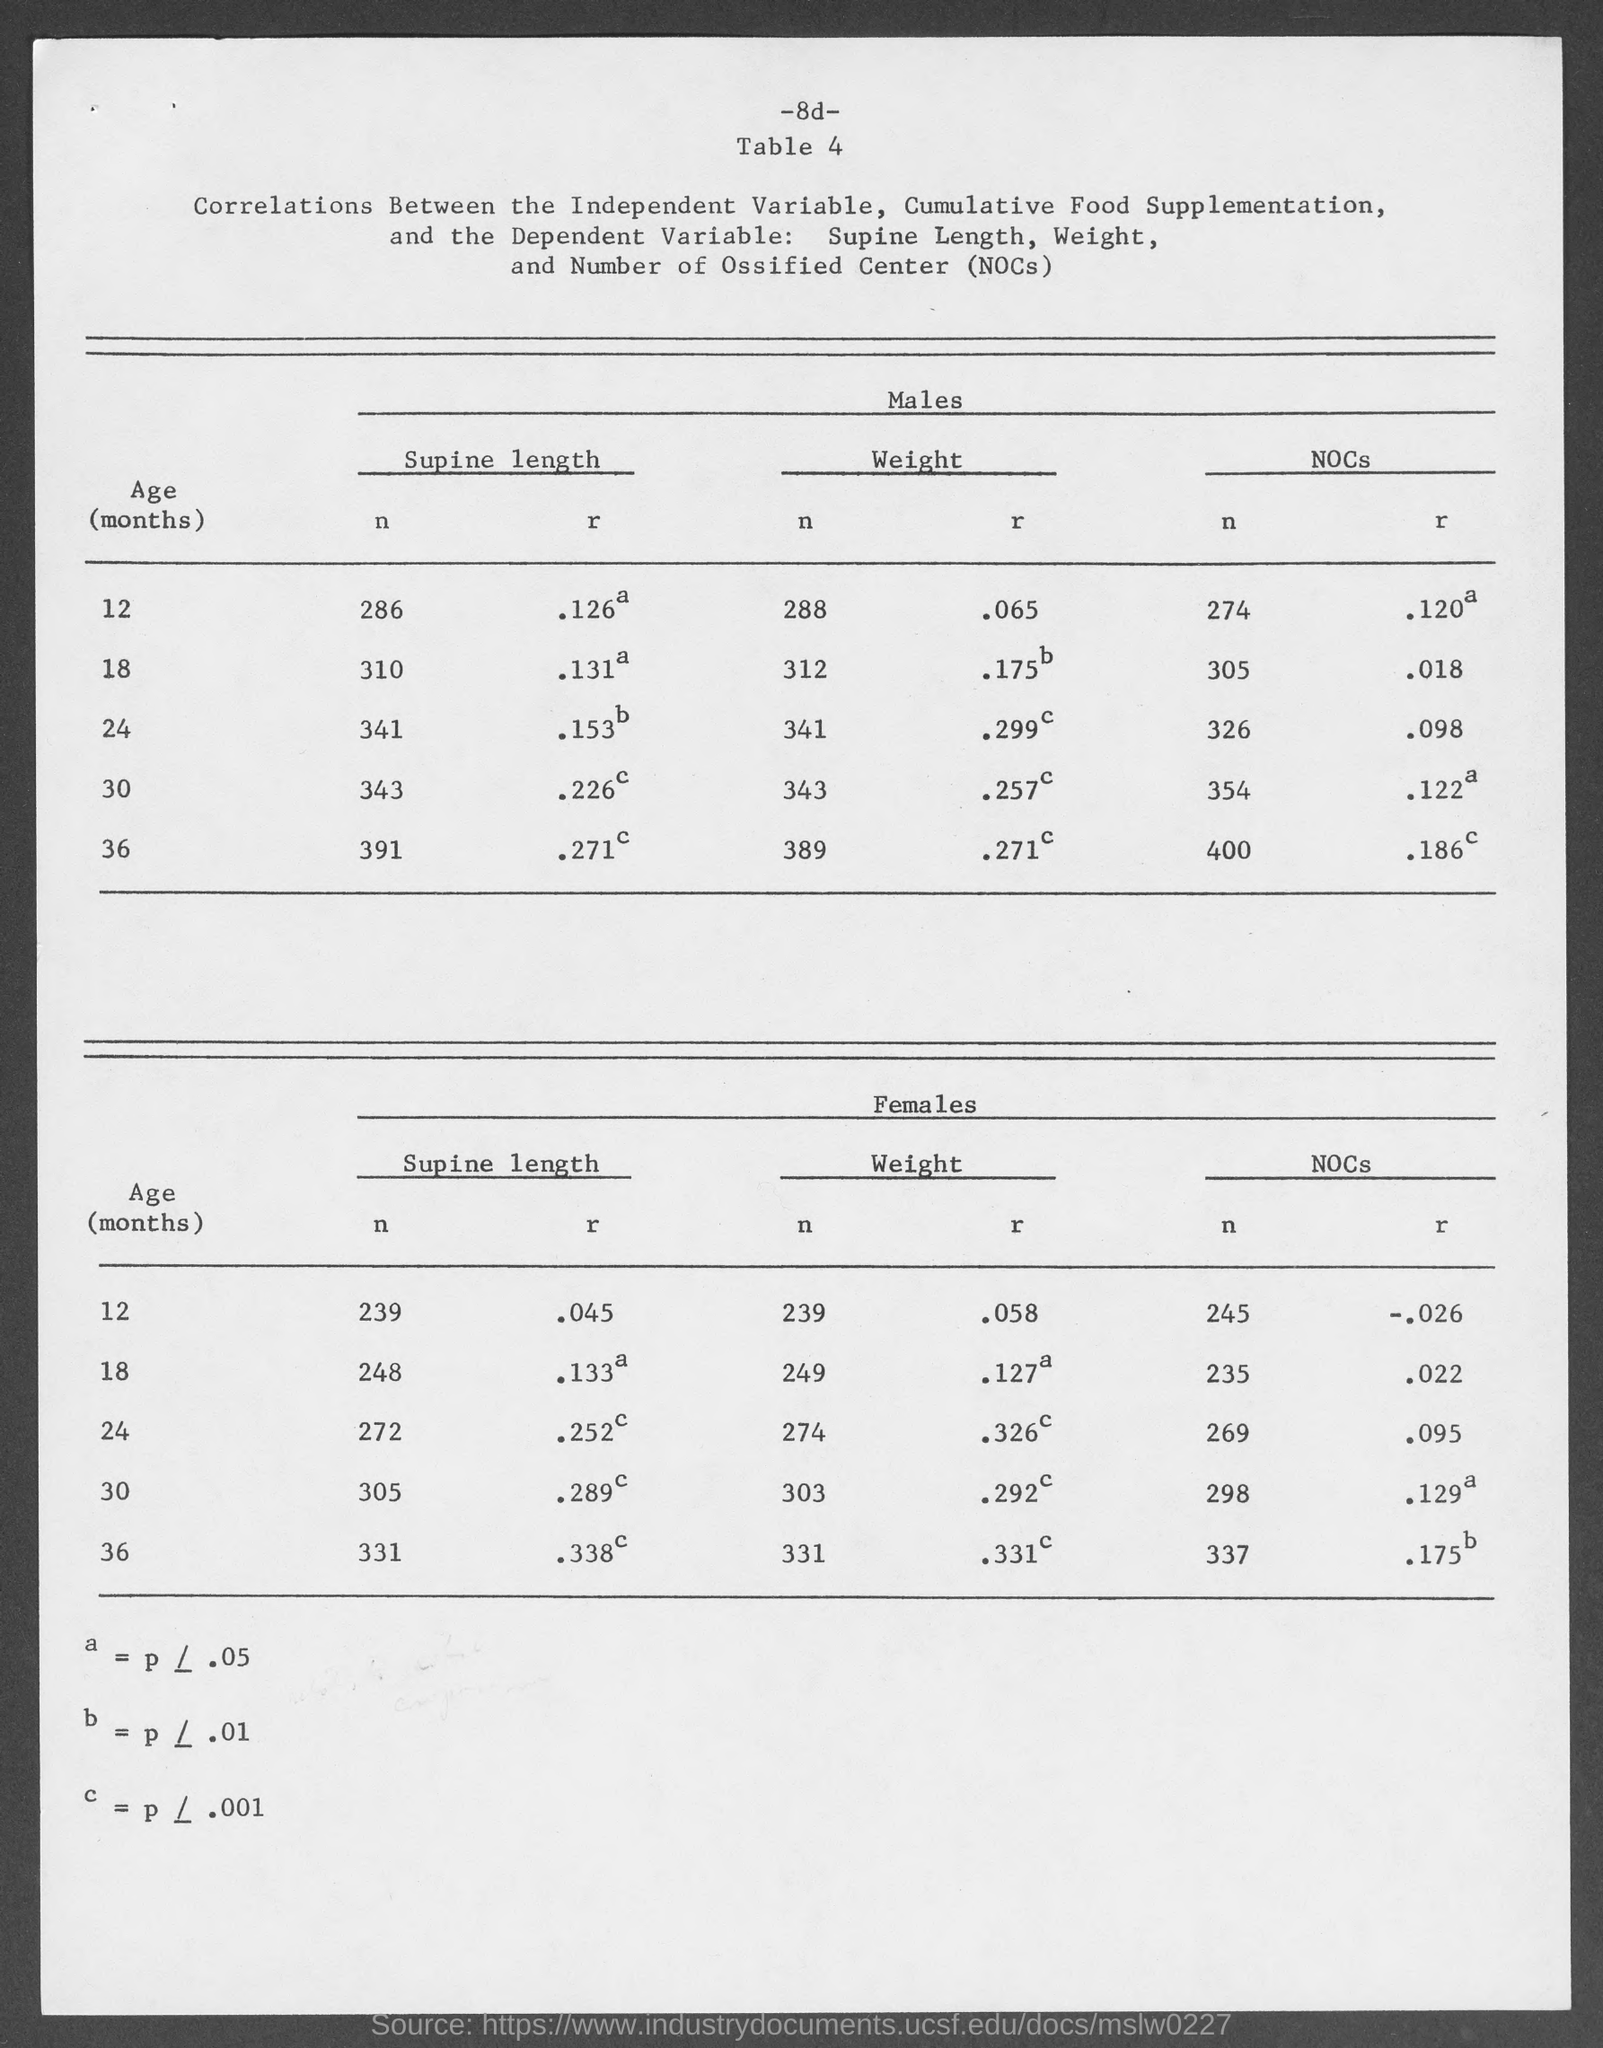Point out several critical features in this image. What is the table number? The table is number 4. 